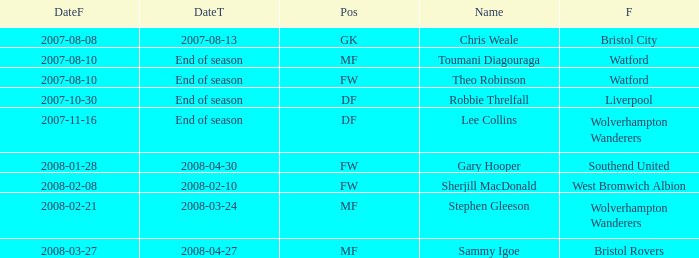What was the Date From for Theo Robinson, who was with the team until the end of season? 2007-08-10. 